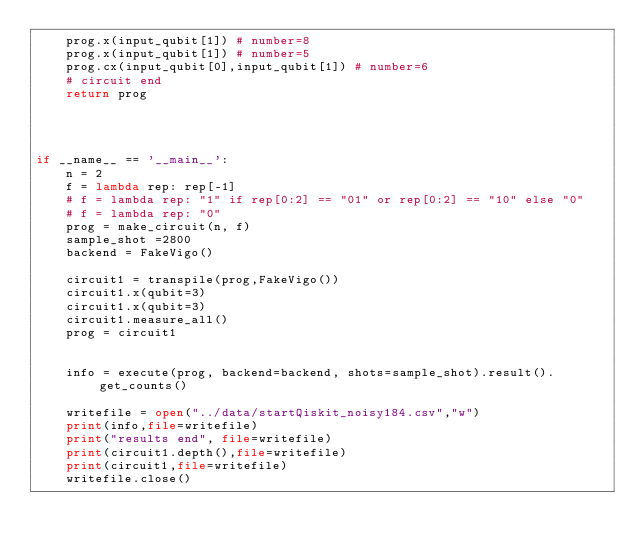Convert code to text. <code><loc_0><loc_0><loc_500><loc_500><_Python_>    prog.x(input_qubit[1]) # number=8
    prog.x(input_qubit[1]) # number=5
    prog.cx(input_qubit[0],input_qubit[1]) # number=6
    # circuit end
    return prog




if __name__ == '__main__':
    n = 2
    f = lambda rep: rep[-1]
    # f = lambda rep: "1" if rep[0:2] == "01" or rep[0:2] == "10" else "0"
    # f = lambda rep: "0"
    prog = make_circuit(n, f)
    sample_shot =2800
    backend = FakeVigo()

    circuit1 = transpile(prog,FakeVigo())
    circuit1.x(qubit=3)
    circuit1.x(qubit=3)
    circuit1.measure_all()
    prog = circuit1


    info = execute(prog, backend=backend, shots=sample_shot).result().get_counts()

    writefile = open("../data/startQiskit_noisy184.csv","w")
    print(info,file=writefile)
    print("results end", file=writefile)
    print(circuit1.depth(),file=writefile)
    print(circuit1,file=writefile)
    writefile.close()
</code> 